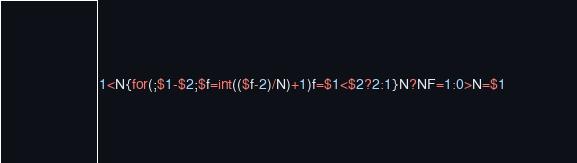Convert code to text. <code><loc_0><loc_0><loc_500><loc_500><_Awk_>1<N{for(;$1-$2;$f=int(($f-2)/N)+1)f=$1<$2?2:1}N?NF=1:0>N=$1</code> 